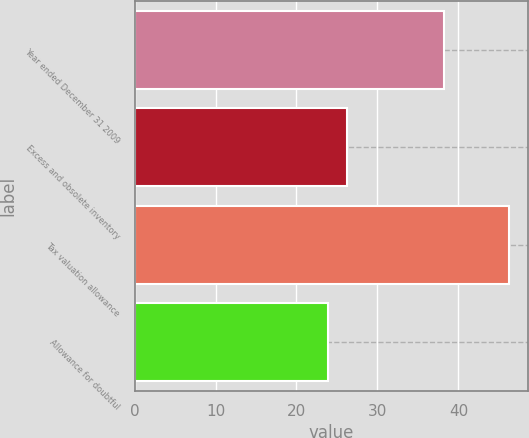Convert chart to OTSL. <chart><loc_0><loc_0><loc_500><loc_500><bar_chart><fcel>Year ended December 31 2009<fcel>Excess and obsolete inventory<fcel>Tax valuation allowance<fcel>Allowance for doubtful<nl><fcel>38.2<fcel>26.2<fcel>46.3<fcel>23.9<nl></chart> 